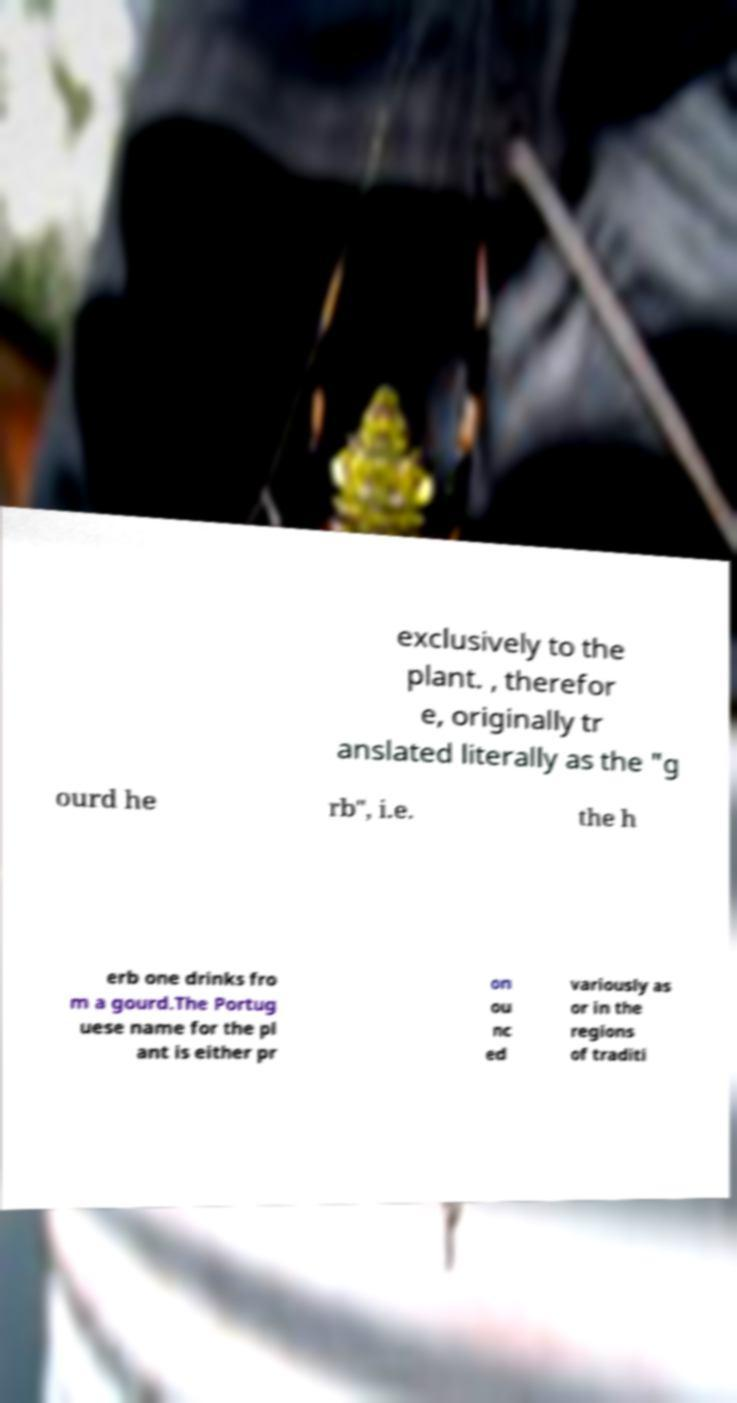For documentation purposes, I need the text within this image transcribed. Could you provide that? exclusively to the plant. , therefor e, originally tr anslated literally as the "g ourd he rb", i.e. the h erb one drinks fro m a gourd.The Portug uese name for the pl ant is either pr on ou nc ed variously as or in the regions of traditi 